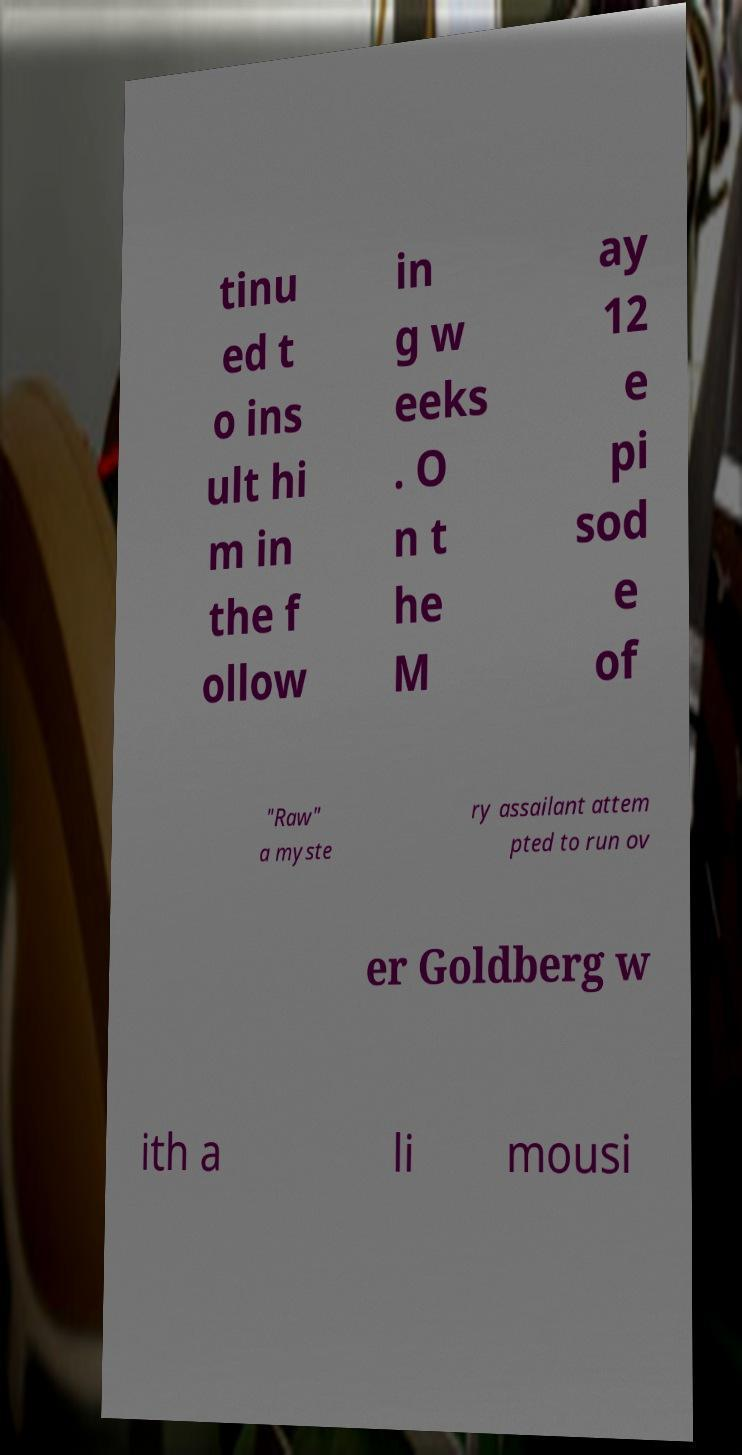Could you extract and type out the text from this image? tinu ed t o ins ult hi m in the f ollow in g w eeks . O n t he M ay 12 e pi sod e of "Raw" a myste ry assailant attem pted to run ov er Goldberg w ith a li mousi 